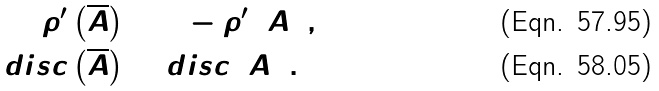<formula> <loc_0><loc_0><loc_500><loc_500>\rho ^ { \prime } \left ( \overline { A } \right ) & = 1 - \rho ^ { \prime } \left ( A \right ) , \\ d i s c \left ( \overline { A } \right ) & = d i s c \left ( A \right ) .</formula> 